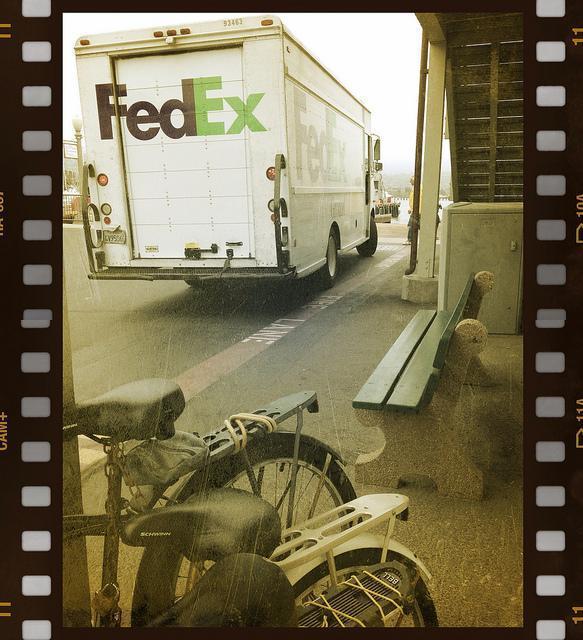How many bicycles are visible?
Give a very brief answer. 3. 